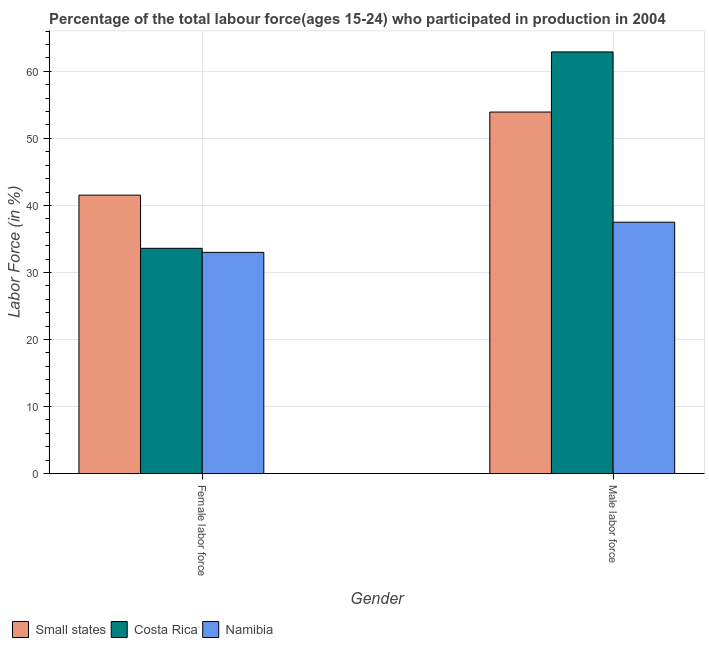How many bars are there on the 1st tick from the right?
Your response must be concise. 3. What is the label of the 1st group of bars from the left?
Provide a short and direct response. Female labor force. What is the percentage of female labor force in Costa Rica?
Offer a very short reply. 33.6. Across all countries, what is the maximum percentage of male labour force?
Offer a very short reply. 62.9. Across all countries, what is the minimum percentage of male labour force?
Give a very brief answer. 37.5. In which country was the percentage of male labour force maximum?
Keep it short and to the point. Costa Rica. In which country was the percentage of male labour force minimum?
Make the answer very short. Namibia. What is the total percentage of male labour force in the graph?
Provide a short and direct response. 154.33. What is the difference between the percentage of female labor force in Costa Rica and that in Small states?
Give a very brief answer. -7.94. What is the difference between the percentage of male labour force in Namibia and the percentage of female labor force in Costa Rica?
Your answer should be compact. 3.9. What is the average percentage of male labour force per country?
Ensure brevity in your answer.  51.44. In how many countries, is the percentage of female labor force greater than 2 %?
Your response must be concise. 3. What is the ratio of the percentage of female labor force in Costa Rica to that in Small states?
Provide a short and direct response. 0.81. In how many countries, is the percentage of female labor force greater than the average percentage of female labor force taken over all countries?
Make the answer very short. 1. What does the 1st bar from the left in Male labor force represents?
Provide a succinct answer. Small states. What does the 3rd bar from the right in Female labor force represents?
Make the answer very short. Small states. How many bars are there?
Keep it short and to the point. 6. Are all the bars in the graph horizontal?
Offer a terse response. No. How many countries are there in the graph?
Your answer should be very brief. 3. What is the difference between two consecutive major ticks on the Y-axis?
Your response must be concise. 10. How are the legend labels stacked?
Give a very brief answer. Horizontal. What is the title of the graph?
Offer a terse response. Percentage of the total labour force(ages 15-24) who participated in production in 2004. Does "Cuba" appear as one of the legend labels in the graph?
Ensure brevity in your answer.  No. What is the label or title of the X-axis?
Provide a short and direct response. Gender. What is the label or title of the Y-axis?
Your answer should be compact. Labor Force (in %). What is the Labor Force (in %) in Small states in Female labor force?
Provide a succinct answer. 41.54. What is the Labor Force (in %) of Costa Rica in Female labor force?
Ensure brevity in your answer.  33.6. What is the Labor Force (in %) in Namibia in Female labor force?
Provide a succinct answer. 33. What is the Labor Force (in %) of Small states in Male labor force?
Offer a very short reply. 53.93. What is the Labor Force (in %) in Costa Rica in Male labor force?
Ensure brevity in your answer.  62.9. What is the Labor Force (in %) of Namibia in Male labor force?
Give a very brief answer. 37.5. Across all Gender, what is the maximum Labor Force (in %) of Small states?
Offer a very short reply. 53.93. Across all Gender, what is the maximum Labor Force (in %) in Costa Rica?
Keep it short and to the point. 62.9. Across all Gender, what is the maximum Labor Force (in %) of Namibia?
Provide a succinct answer. 37.5. Across all Gender, what is the minimum Labor Force (in %) of Small states?
Your answer should be compact. 41.54. Across all Gender, what is the minimum Labor Force (in %) of Costa Rica?
Keep it short and to the point. 33.6. What is the total Labor Force (in %) in Small states in the graph?
Provide a short and direct response. 95.46. What is the total Labor Force (in %) of Costa Rica in the graph?
Make the answer very short. 96.5. What is the total Labor Force (in %) in Namibia in the graph?
Your answer should be very brief. 70.5. What is the difference between the Labor Force (in %) of Small states in Female labor force and that in Male labor force?
Your answer should be very brief. -12.39. What is the difference between the Labor Force (in %) in Costa Rica in Female labor force and that in Male labor force?
Offer a terse response. -29.3. What is the difference between the Labor Force (in %) in Small states in Female labor force and the Labor Force (in %) in Costa Rica in Male labor force?
Offer a terse response. -21.36. What is the difference between the Labor Force (in %) in Small states in Female labor force and the Labor Force (in %) in Namibia in Male labor force?
Make the answer very short. 4.04. What is the difference between the Labor Force (in %) in Costa Rica in Female labor force and the Labor Force (in %) in Namibia in Male labor force?
Provide a succinct answer. -3.9. What is the average Labor Force (in %) of Small states per Gender?
Ensure brevity in your answer.  47.73. What is the average Labor Force (in %) of Costa Rica per Gender?
Offer a terse response. 48.25. What is the average Labor Force (in %) in Namibia per Gender?
Give a very brief answer. 35.25. What is the difference between the Labor Force (in %) of Small states and Labor Force (in %) of Costa Rica in Female labor force?
Your response must be concise. 7.94. What is the difference between the Labor Force (in %) of Small states and Labor Force (in %) of Namibia in Female labor force?
Keep it short and to the point. 8.54. What is the difference between the Labor Force (in %) in Costa Rica and Labor Force (in %) in Namibia in Female labor force?
Provide a succinct answer. 0.6. What is the difference between the Labor Force (in %) of Small states and Labor Force (in %) of Costa Rica in Male labor force?
Your response must be concise. -8.97. What is the difference between the Labor Force (in %) in Small states and Labor Force (in %) in Namibia in Male labor force?
Your answer should be compact. 16.43. What is the difference between the Labor Force (in %) in Costa Rica and Labor Force (in %) in Namibia in Male labor force?
Your answer should be compact. 25.4. What is the ratio of the Labor Force (in %) in Small states in Female labor force to that in Male labor force?
Give a very brief answer. 0.77. What is the ratio of the Labor Force (in %) of Costa Rica in Female labor force to that in Male labor force?
Offer a very short reply. 0.53. What is the difference between the highest and the second highest Labor Force (in %) in Small states?
Keep it short and to the point. 12.39. What is the difference between the highest and the second highest Labor Force (in %) of Costa Rica?
Make the answer very short. 29.3. What is the difference between the highest and the lowest Labor Force (in %) in Small states?
Offer a very short reply. 12.39. What is the difference between the highest and the lowest Labor Force (in %) of Costa Rica?
Give a very brief answer. 29.3. 